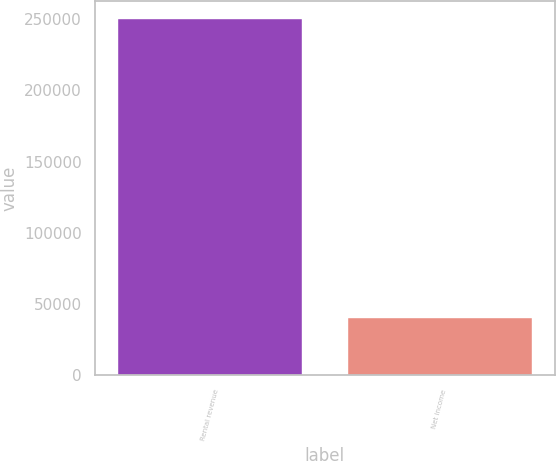Convert chart to OTSL. <chart><loc_0><loc_0><loc_500><loc_500><bar_chart><fcel>Rental revenue<fcel>Net income<nl><fcel>250312<fcel>40437<nl></chart> 